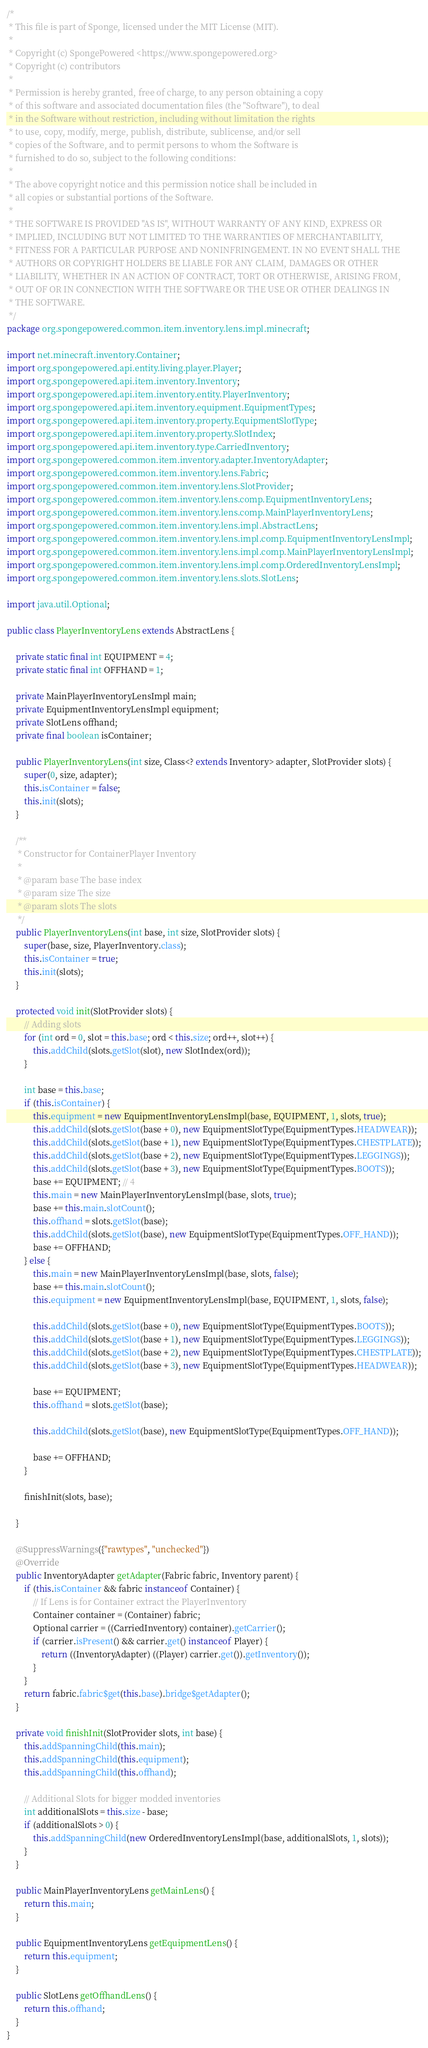<code> <loc_0><loc_0><loc_500><loc_500><_Java_>/*
 * This file is part of Sponge, licensed under the MIT License (MIT).
 *
 * Copyright (c) SpongePowered <https://www.spongepowered.org>
 * Copyright (c) contributors
 *
 * Permission is hereby granted, free of charge, to any person obtaining a copy
 * of this software and associated documentation files (the "Software"), to deal
 * in the Software without restriction, including without limitation the rights
 * to use, copy, modify, merge, publish, distribute, sublicense, and/or sell
 * copies of the Software, and to permit persons to whom the Software is
 * furnished to do so, subject to the following conditions:
 *
 * The above copyright notice and this permission notice shall be included in
 * all copies or substantial portions of the Software.
 *
 * THE SOFTWARE IS PROVIDED "AS IS", WITHOUT WARRANTY OF ANY KIND, EXPRESS OR
 * IMPLIED, INCLUDING BUT NOT LIMITED TO THE WARRANTIES OF MERCHANTABILITY,
 * FITNESS FOR A PARTICULAR PURPOSE AND NONINFRINGEMENT. IN NO EVENT SHALL THE
 * AUTHORS OR COPYRIGHT HOLDERS BE LIABLE FOR ANY CLAIM, DAMAGES OR OTHER
 * LIABILITY, WHETHER IN AN ACTION OF CONTRACT, TORT OR OTHERWISE, ARISING FROM,
 * OUT OF OR IN CONNECTION WITH THE SOFTWARE OR THE USE OR OTHER DEALINGS IN
 * THE SOFTWARE.
 */
package org.spongepowered.common.item.inventory.lens.impl.minecraft;

import net.minecraft.inventory.Container;
import org.spongepowered.api.entity.living.player.Player;
import org.spongepowered.api.item.inventory.Inventory;
import org.spongepowered.api.item.inventory.entity.PlayerInventory;
import org.spongepowered.api.item.inventory.equipment.EquipmentTypes;
import org.spongepowered.api.item.inventory.property.EquipmentSlotType;
import org.spongepowered.api.item.inventory.property.SlotIndex;
import org.spongepowered.api.item.inventory.type.CarriedInventory;
import org.spongepowered.common.item.inventory.adapter.InventoryAdapter;
import org.spongepowered.common.item.inventory.lens.Fabric;
import org.spongepowered.common.item.inventory.lens.SlotProvider;
import org.spongepowered.common.item.inventory.lens.comp.EquipmentInventoryLens;
import org.spongepowered.common.item.inventory.lens.comp.MainPlayerInventoryLens;
import org.spongepowered.common.item.inventory.lens.impl.AbstractLens;
import org.spongepowered.common.item.inventory.lens.impl.comp.EquipmentInventoryLensImpl;
import org.spongepowered.common.item.inventory.lens.impl.comp.MainPlayerInventoryLensImpl;
import org.spongepowered.common.item.inventory.lens.impl.comp.OrderedInventoryLensImpl;
import org.spongepowered.common.item.inventory.lens.slots.SlotLens;

import java.util.Optional;

public class PlayerInventoryLens extends AbstractLens {

    private static final int EQUIPMENT = 4;
    private static final int OFFHAND = 1;

    private MainPlayerInventoryLensImpl main;
    private EquipmentInventoryLensImpl equipment;
    private SlotLens offhand;
    private final boolean isContainer;

    public PlayerInventoryLens(int size, Class<? extends Inventory> adapter, SlotProvider slots) {
        super(0, size, adapter);
        this.isContainer = false;
        this.init(slots);
    }

    /**
     * Constructor for ContainerPlayer Inventory
     *
     * @param base The base index
     * @param size The size
     * @param slots The slots
     */
    public PlayerInventoryLens(int base, int size, SlotProvider slots) {
        super(base, size, PlayerInventory.class);
        this.isContainer = true;
        this.init(slots);
    }

    protected void init(SlotProvider slots) {
        // Adding slots
        for (int ord = 0, slot = this.base; ord < this.size; ord++, slot++) {
            this.addChild(slots.getSlot(slot), new SlotIndex(ord));
        }

        int base = this.base;
        if (this.isContainer) {
            this.equipment = new EquipmentInventoryLensImpl(base, EQUIPMENT, 1, slots, true);
            this.addChild(slots.getSlot(base + 0), new EquipmentSlotType(EquipmentTypes.HEADWEAR));
            this.addChild(slots.getSlot(base + 1), new EquipmentSlotType(EquipmentTypes.CHESTPLATE));
            this.addChild(slots.getSlot(base + 2), new EquipmentSlotType(EquipmentTypes.LEGGINGS));
            this.addChild(slots.getSlot(base + 3), new EquipmentSlotType(EquipmentTypes.BOOTS));
            base += EQUIPMENT; // 4
            this.main = new MainPlayerInventoryLensImpl(base, slots, true);
            base += this.main.slotCount();
            this.offhand = slots.getSlot(base);
            this.addChild(slots.getSlot(base), new EquipmentSlotType(EquipmentTypes.OFF_HAND));
            base += OFFHAND;
        } else {
            this.main = new MainPlayerInventoryLensImpl(base, slots, false);
            base += this.main.slotCount();
            this.equipment = new EquipmentInventoryLensImpl(base, EQUIPMENT, 1, slots, false);

            this.addChild(slots.getSlot(base + 0), new EquipmentSlotType(EquipmentTypes.BOOTS));
            this.addChild(slots.getSlot(base + 1), new EquipmentSlotType(EquipmentTypes.LEGGINGS));
            this.addChild(slots.getSlot(base + 2), new EquipmentSlotType(EquipmentTypes.CHESTPLATE));
            this.addChild(slots.getSlot(base + 3), new EquipmentSlotType(EquipmentTypes.HEADWEAR));

            base += EQUIPMENT;
            this.offhand = slots.getSlot(base);

            this.addChild(slots.getSlot(base), new EquipmentSlotType(EquipmentTypes.OFF_HAND));

            base += OFFHAND;
        }

        finishInit(slots, base);

    }

    @SuppressWarnings({"rawtypes", "unchecked"})
    @Override
    public InventoryAdapter getAdapter(Fabric fabric, Inventory parent) {
        if (this.isContainer && fabric instanceof Container) {
            // If Lens is for Container extract the PlayerInventory
            Container container = (Container) fabric;
            Optional carrier = ((CarriedInventory) container).getCarrier();
            if (carrier.isPresent() && carrier.get() instanceof Player) {
                return ((InventoryAdapter) ((Player) carrier.get()).getInventory());
            }
        }
        return fabric.fabric$get(this.base).bridge$getAdapter();
    }

    private void finishInit(SlotProvider slots, int base) {
        this.addSpanningChild(this.main);
        this.addSpanningChild(this.equipment);
        this.addSpanningChild(this.offhand);

        // Additional Slots for bigger modded inventories
        int additionalSlots = this.size - base;
        if (additionalSlots > 0) {
            this.addSpanningChild(new OrderedInventoryLensImpl(base, additionalSlots, 1, slots));
        }
    }

    public MainPlayerInventoryLens getMainLens() {
        return this.main;
    }

    public EquipmentInventoryLens getEquipmentLens() {
        return this.equipment;
    }

    public SlotLens getOffhandLens() {
        return this.offhand;
    }
}
</code> 